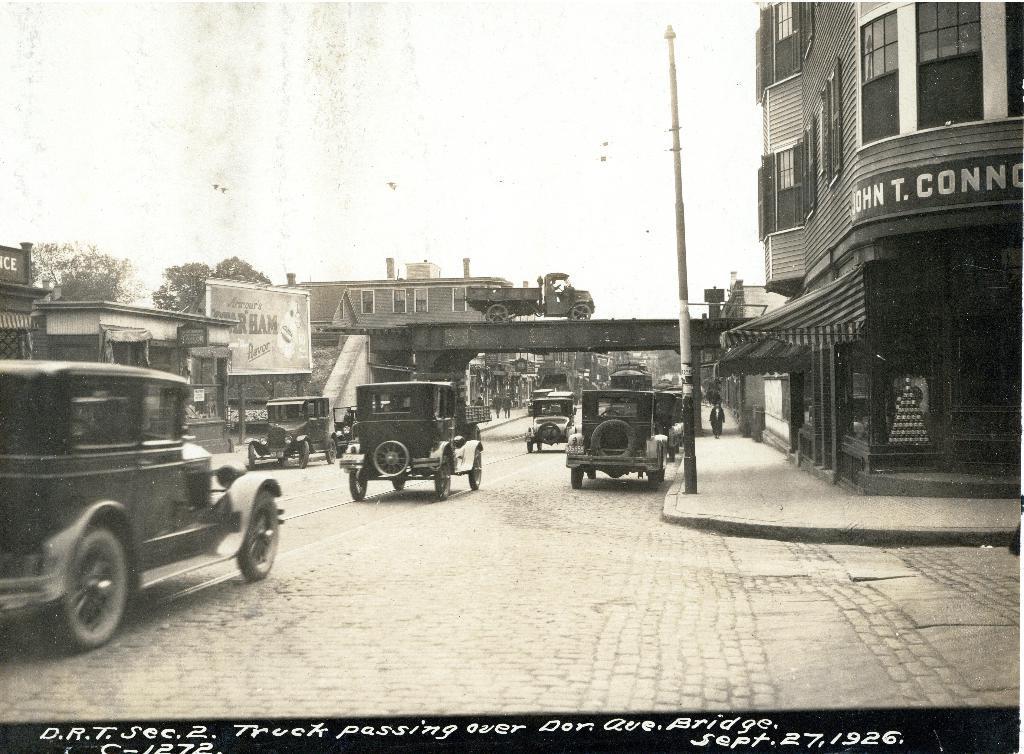Describe this image in one or two sentences. In this image we can see vehicles on the road. In the background there is a bridge, buildings, trees, poles and sky. 